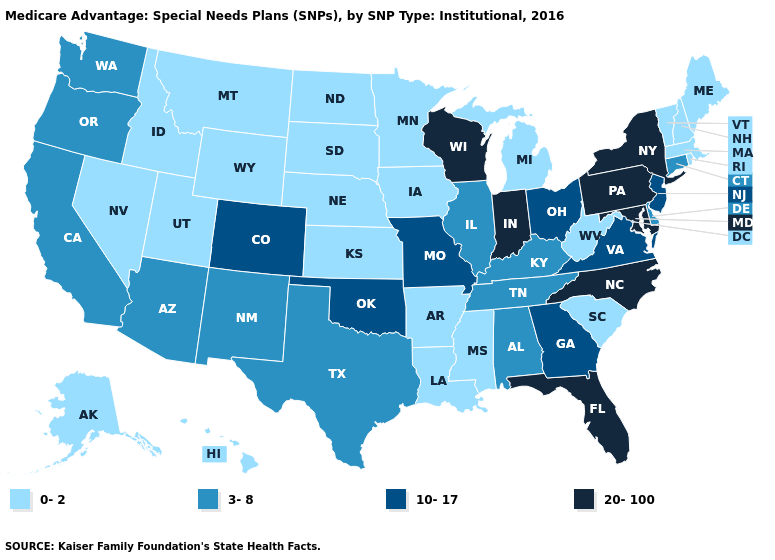Which states have the lowest value in the USA?
Answer briefly. Alaska, Arkansas, Hawaii, Iowa, Idaho, Kansas, Louisiana, Massachusetts, Maine, Michigan, Minnesota, Mississippi, Montana, North Dakota, Nebraska, New Hampshire, Nevada, Rhode Island, South Carolina, South Dakota, Utah, Vermont, West Virginia, Wyoming. What is the highest value in the South ?
Answer briefly. 20-100. What is the highest value in the MidWest ?
Keep it brief. 20-100. Which states have the lowest value in the Northeast?
Concise answer only. Massachusetts, Maine, New Hampshire, Rhode Island, Vermont. What is the highest value in states that border Louisiana?
Short answer required. 3-8. What is the value of New York?
Be succinct. 20-100. Which states have the highest value in the USA?
Quick response, please. Florida, Indiana, Maryland, North Carolina, New York, Pennsylvania, Wisconsin. What is the value of Vermont?
Be succinct. 0-2. What is the value of North Carolina?
Give a very brief answer. 20-100. Which states have the lowest value in the West?
Write a very short answer. Alaska, Hawaii, Idaho, Montana, Nevada, Utah, Wyoming. Which states hav the highest value in the MidWest?
Short answer required. Indiana, Wisconsin. What is the value of South Dakota?
Keep it brief. 0-2. Among the states that border Florida , which have the lowest value?
Short answer required. Alabama. Among the states that border Connecticut , which have the highest value?
Concise answer only. New York. What is the value of Kentucky?
Keep it brief. 3-8. 